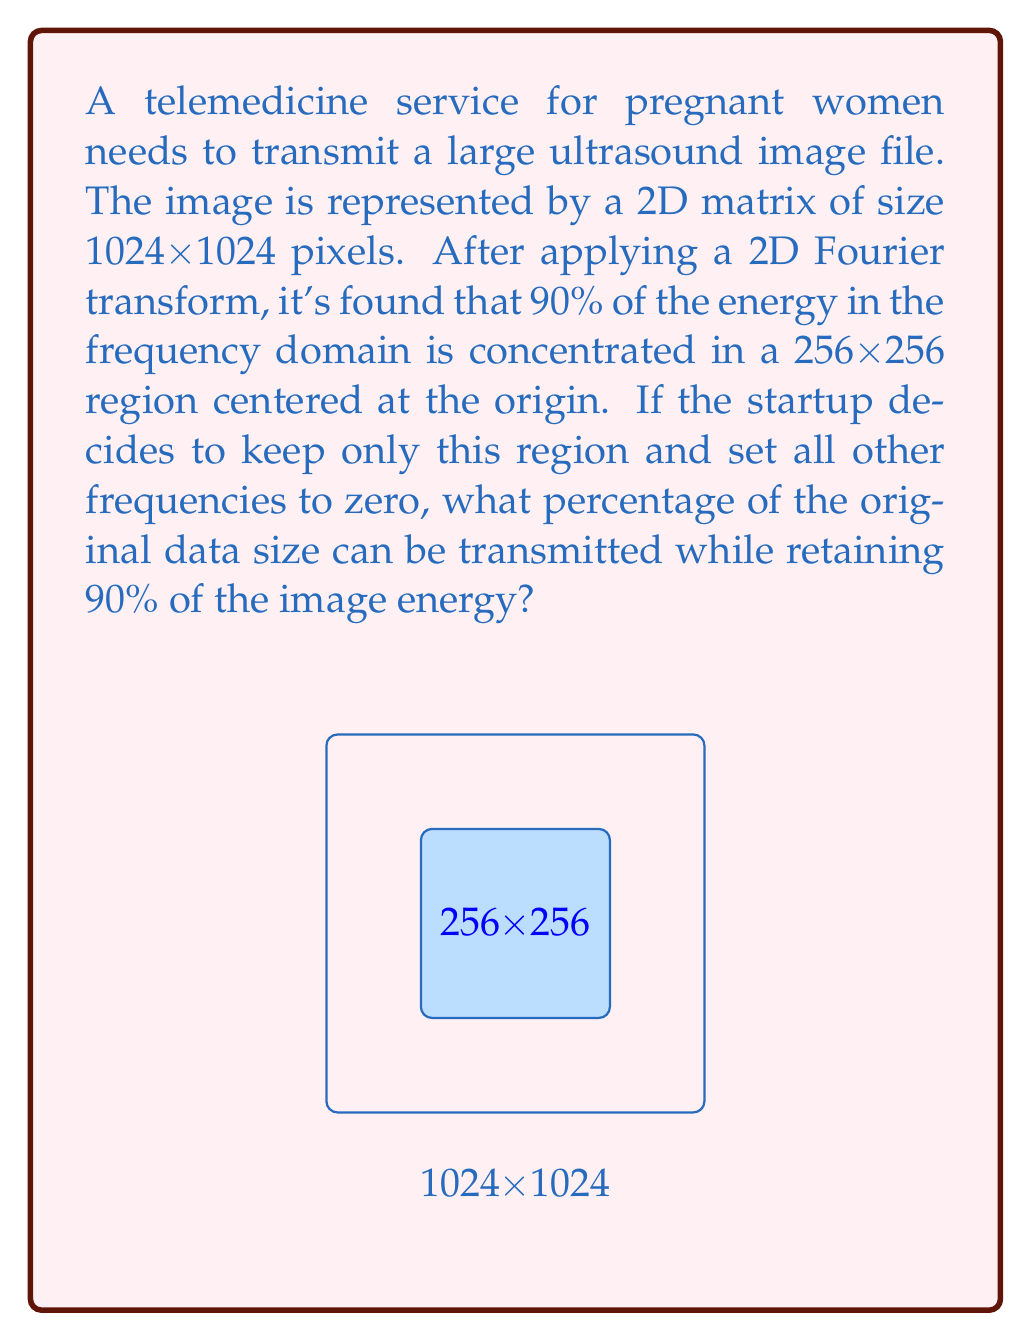Solve this math problem. Let's approach this step-by-step:

1) The original image size is 1024x1024 pixels, which means the total number of pixels is:
   $$N_{original} = 1024 \times 1024 = 1,048,576$$

2) After the Fourier transform, we're keeping a 256x256 region, so the number of pixels we're retaining is:
   $$N_{retained} = 256 \times 256 = 65,536$$

3) To calculate the percentage of the original data size that we're transmitting, we use:
   $$\text{Percentage} = \frac{N_{retained}}{N_{original}} \times 100\%$$

4) Substituting our values:
   $$\text{Percentage} = \frac{65,536}{1,048,576} \times 100\% = 0.0625 \times 100\% = 6.25\%$$

5) This means we're transmitting only 6.25% of the original data size while retaining 90% of the image energy.

The Fourier transform allows us to compress the image by focusing on the most significant frequency components, which often contain most of the image's energy. This is particularly useful in telemedicine applications where efficient data transmission is crucial.
Answer: 6.25% 